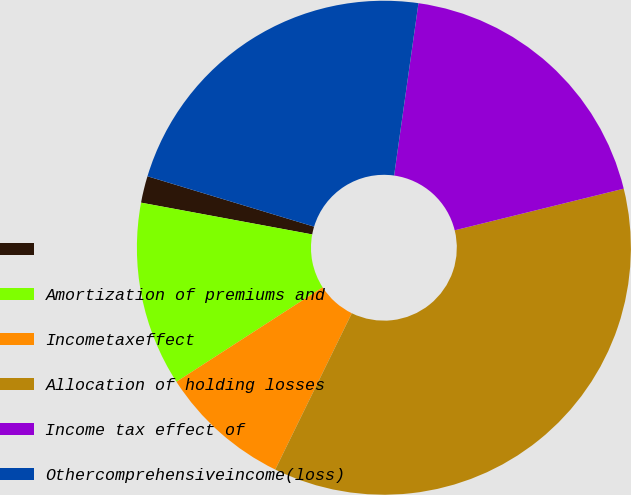Convert chart. <chart><loc_0><loc_0><loc_500><loc_500><pie_chart><ecel><fcel>Amortization of premiums and<fcel>Incometaxeffect<fcel>Allocation of holding losses<fcel>Income tax effect of<fcel>Othercomprehensiveincome(loss)<nl><fcel>1.75%<fcel>12.05%<fcel>8.62%<fcel>36.09%<fcel>18.92%<fcel>22.56%<nl></chart> 